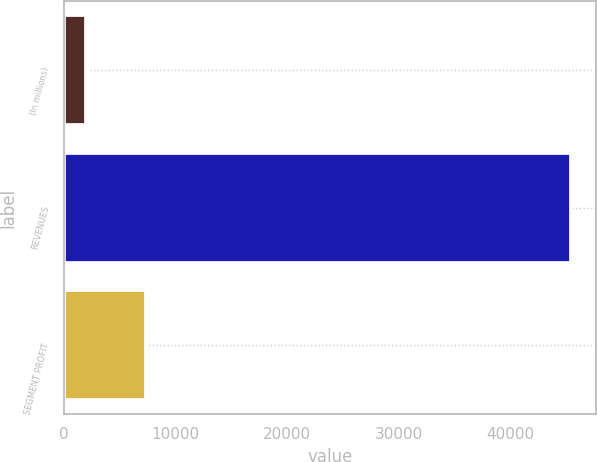<chart> <loc_0><loc_0><loc_500><loc_500><bar_chart><fcel>(In millions)<fcel>REVENUES<fcel>SEGMENT PROFIT<nl><fcel>2012<fcel>45364<fcel>7345<nl></chart> 